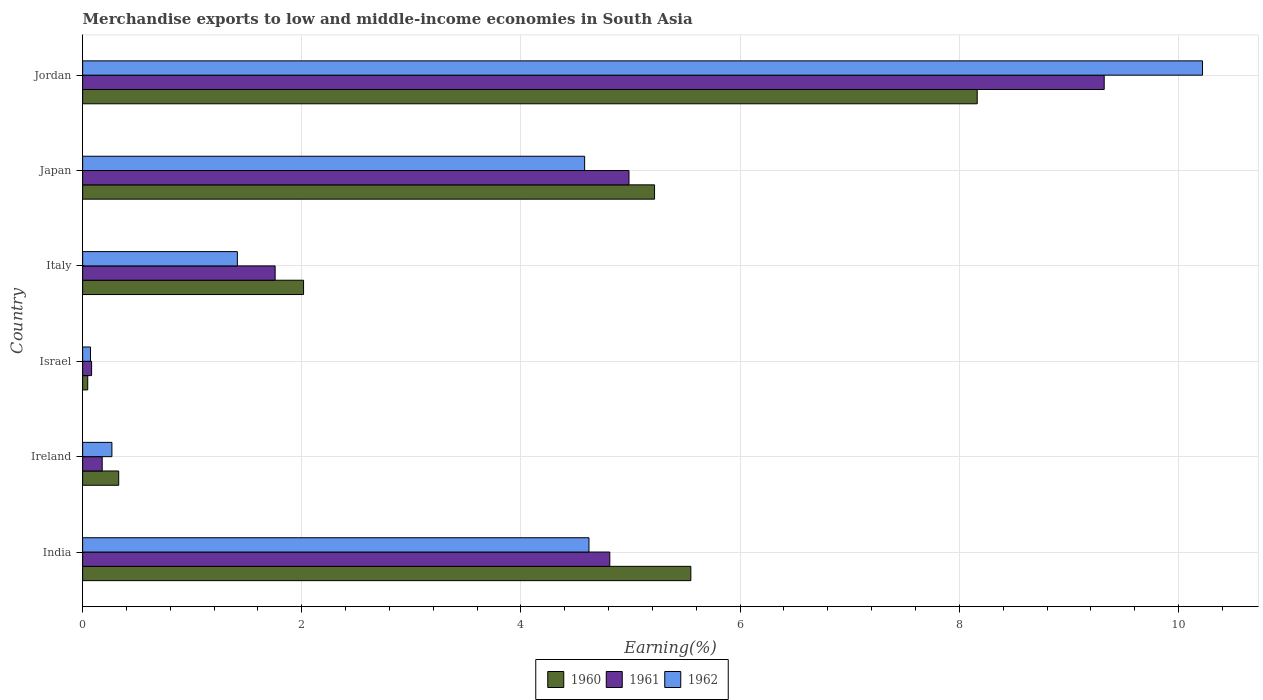How many different coloured bars are there?
Ensure brevity in your answer.  3. Are the number of bars per tick equal to the number of legend labels?
Your answer should be very brief. Yes. Are the number of bars on each tick of the Y-axis equal?
Offer a terse response. Yes. How many bars are there on the 3rd tick from the top?
Your response must be concise. 3. How many bars are there on the 2nd tick from the bottom?
Offer a very short reply. 3. What is the label of the 4th group of bars from the top?
Keep it short and to the point. Israel. In how many cases, is the number of bars for a given country not equal to the number of legend labels?
Offer a very short reply. 0. What is the percentage of amount earned from merchandise exports in 1960 in Jordan?
Your answer should be compact. 8.16. Across all countries, what is the maximum percentage of amount earned from merchandise exports in 1961?
Your answer should be very brief. 9.32. Across all countries, what is the minimum percentage of amount earned from merchandise exports in 1961?
Give a very brief answer. 0.08. In which country was the percentage of amount earned from merchandise exports in 1962 maximum?
Provide a succinct answer. Jordan. What is the total percentage of amount earned from merchandise exports in 1961 in the graph?
Your answer should be very brief. 21.13. What is the difference between the percentage of amount earned from merchandise exports in 1962 in Israel and that in Italy?
Offer a very short reply. -1.34. What is the difference between the percentage of amount earned from merchandise exports in 1960 in India and the percentage of amount earned from merchandise exports in 1961 in Ireland?
Keep it short and to the point. 5.37. What is the average percentage of amount earned from merchandise exports in 1962 per country?
Your response must be concise. 3.53. What is the difference between the percentage of amount earned from merchandise exports in 1961 and percentage of amount earned from merchandise exports in 1962 in Ireland?
Give a very brief answer. -0.09. In how many countries, is the percentage of amount earned from merchandise exports in 1962 greater than 4.4 %?
Ensure brevity in your answer.  3. What is the ratio of the percentage of amount earned from merchandise exports in 1962 in India to that in Ireland?
Provide a short and direct response. 17.29. Is the percentage of amount earned from merchandise exports in 1961 in Israel less than that in Japan?
Provide a succinct answer. Yes. What is the difference between the highest and the second highest percentage of amount earned from merchandise exports in 1960?
Give a very brief answer. 2.61. What is the difference between the highest and the lowest percentage of amount earned from merchandise exports in 1961?
Provide a succinct answer. 9.24. In how many countries, is the percentage of amount earned from merchandise exports in 1960 greater than the average percentage of amount earned from merchandise exports in 1960 taken over all countries?
Your answer should be very brief. 3. Is the sum of the percentage of amount earned from merchandise exports in 1962 in Ireland and Israel greater than the maximum percentage of amount earned from merchandise exports in 1960 across all countries?
Make the answer very short. No. What does the 3rd bar from the bottom in Japan represents?
Offer a very short reply. 1962. Is it the case that in every country, the sum of the percentage of amount earned from merchandise exports in 1962 and percentage of amount earned from merchandise exports in 1961 is greater than the percentage of amount earned from merchandise exports in 1960?
Provide a succinct answer. Yes. Are all the bars in the graph horizontal?
Your response must be concise. Yes. How many countries are there in the graph?
Offer a very short reply. 6. What is the difference between two consecutive major ticks on the X-axis?
Your answer should be compact. 2. Where does the legend appear in the graph?
Offer a terse response. Bottom center. How many legend labels are there?
Offer a terse response. 3. How are the legend labels stacked?
Provide a succinct answer. Horizontal. What is the title of the graph?
Ensure brevity in your answer.  Merchandise exports to low and middle-income economies in South Asia. What is the label or title of the X-axis?
Provide a succinct answer. Earning(%). What is the Earning(%) in 1960 in India?
Give a very brief answer. 5.55. What is the Earning(%) of 1961 in India?
Your answer should be very brief. 4.81. What is the Earning(%) of 1962 in India?
Your answer should be compact. 4.62. What is the Earning(%) in 1960 in Ireland?
Offer a terse response. 0.33. What is the Earning(%) in 1961 in Ireland?
Provide a succinct answer. 0.18. What is the Earning(%) of 1962 in Ireland?
Make the answer very short. 0.27. What is the Earning(%) in 1960 in Israel?
Provide a short and direct response. 0.05. What is the Earning(%) of 1961 in Israel?
Offer a very short reply. 0.08. What is the Earning(%) in 1962 in Israel?
Offer a very short reply. 0.07. What is the Earning(%) of 1960 in Italy?
Your answer should be very brief. 2.02. What is the Earning(%) in 1961 in Italy?
Provide a succinct answer. 1.76. What is the Earning(%) in 1962 in Italy?
Ensure brevity in your answer.  1.41. What is the Earning(%) in 1960 in Japan?
Give a very brief answer. 5.22. What is the Earning(%) in 1961 in Japan?
Offer a very short reply. 4.99. What is the Earning(%) of 1962 in Japan?
Give a very brief answer. 4.58. What is the Earning(%) in 1960 in Jordan?
Provide a succinct answer. 8.16. What is the Earning(%) in 1961 in Jordan?
Give a very brief answer. 9.32. What is the Earning(%) of 1962 in Jordan?
Your answer should be compact. 10.22. Across all countries, what is the maximum Earning(%) in 1960?
Provide a short and direct response. 8.16. Across all countries, what is the maximum Earning(%) in 1961?
Provide a short and direct response. 9.32. Across all countries, what is the maximum Earning(%) of 1962?
Your answer should be compact. 10.22. Across all countries, what is the minimum Earning(%) of 1960?
Give a very brief answer. 0.05. Across all countries, what is the minimum Earning(%) of 1961?
Ensure brevity in your answer.  0.08. Across all countries, what is the minimum Earning(%) in 1962?
Make the answer very short. 0.07. What is the total Earning(%) of 1960 in the graph?
Your answer should be compact. 21.32. What is the total Earning(%) in 1961 in the graph?
Keep it short and to the point. 21.14. What is the total Earning(%) of 1962 in the graph?
Make the answer very short. 21.17. What is the difference between the Earning(%) in 1960 in India and that in Ireland?
Provide a succinct answer. 5.22. What is the difference between the Earning(%) in 1961 in India and that in Ireland?
Your response must be concise. 4.63. What is the difference between the Earning(%) in 1962 in India and that in Ireland?
Make the answer very short. 4.35. What is the difference between the Earning(%) of 1960 in India and that in Israel?
Provide a short and direct response. 5.5. What is the difference between the Earning(%) of 1961 in India and that in Israel?
Keep it short and to the point. 4.73. What is the difference between the Earning(%) of 1962 in India and that in Israel?
Your response must be concise. 4.55. What is the difference between the Earning(%) of 1960 in India and that in Italy?
Offer a very short reply. 3.53. What is the difference between the Earning(%) in 1961 in India and that in Italy?
Provide a short and direct response. 3.05. What is the difference between the Earning(%) in 1962 in India and that in Italy?
Provide a short and direct response. 3.21. What is the difference between the Earning(%) of 1960 in India and that in Japan?
Give a very brief answer. 0.33. What is the difference between the Earning(%) in 1961 in India and that in Japan?
Offer a very short reply. -0.17. What is the difference between the Earning(%) in 1962 in India and that in Japan?
Offer a very short reply. 0.04. What is the difference between the Earning(%) of 1960 in India and that in Jordan?
Keep it short and to the point. -2.61. What is the difference between the Earning(%) in 1961 in India and that in Jordan?
Your response must be concise. -4.51. What is the difference between the Earning(%) in 1962 in India and that in Jordan?
Provide a succinct answer. -5.6. What is the difference between the Earning(%) in 1960 in Ireland and that in Israel?
Offer a very short reply. 0.28. What is the difference between the Earning(%) in 1961 in Ireland and that in Israel?
Offer a terse response. 0.1. What is the difference between the Earning(%) in 1962 in Ireland and that in Israel?
Provide a short and direct response. 0.2. What is the difference between the Earning(%) in 1960 in Ireland and that in Italy?
Give a very brief answer. -1.69. What is the difference between the Earning(%) in 1961 in Ireland and that in Italy?
Offer a very short reply. -1.58. What is the difference between the Earning(%) of 1962 in Ireland and that in Italy?
Ensure brevity in your answer.  -1.14. What is the difference between the Earning(%) of 1960 in Ireland and that in Japan?
Offer a terse response. -4.89. What is the difference between the Earning(%) in 1961 in Ireland and that in Japan?
Keep it short and to the point. -4.81. What is the difference between the Earning(%) of 1962 in Ireland and that in Japan?
Make the answer very short. -4.31. What is the difference between the Earning(%) in 1960 in Ireland and that in Jordan?
Ensure brevity in your answer.  -7.83. What is the difference between the Earning(%) of 1961 in Ireland and that in Jordan?
Make the answer very short. -9.14. What is the difference between the Earning(%) in 1962 in Ireland and that in Jordan?
Provide a short and direct response. -9.95. What is the difference between the Earning(%) in 1960 in Israel and that in Italy?
Your answer should be compact. -1.97. What is the difference between the Earning(%) in 1961 in Israel and that in Italy?
Provide a succinct answer. -1.68. What is the difference between the Earning(%) in 1962 in Israel and that in Italy?
Give a very brief answer. -1.34. What is the difference between the Earning(%) of 1960 in Israel and that in Japan?
Provide a short and direct response. -5.17. What is the difference between the Earning(%) of 1961 in Israel and that in Japan?
Offer a terse response. -4.9. What is the difference between the Earning(%) in 1962 in Israel and that in Japan?
Ensure brevity in your answer.  -4.51. What is the difference between the Earning(%) in 1960 in Israel and that in Jordan?
Offer a terse response. -8.12. What is the difference between the Earning(%) in 1961 in Israel and that in Jordan?
Ensure brevity in your answer.  -9.24. What is the difference between the Earning(%) of 1962 in Israel and that in Jordan?
Offer a very short reply. -10.15. What is the difference between the Earning(%) of 1960 in Italy and that in Japan?
Give a very brief answer. -3.2. What is the difference between the Earning(%) in 1961 in Italy and that in Japan?
Your answer should be very brief. -3.23. What is the difference between the Earning(%) in 1962 in Italy and that in Japan?
Your response must be concise. -3.17. What is the difference between the Earning(%) in 1960 in Italy and that in Jordan?
Give a very brief answer. -6.15. What is the difference between the Earning(%) of 1961 in Italy and that in Jordan?
Make the answer very short. -7.57. What is the difference between the Earning(%) in 1962 in Italy and that in Jordan?
Ensure brevity in your answer.  -8.81. What is the difference between the Earning(%) in 1960 in Japan and that in Jordan?
Provide a short and direct response. -2.94. What is the difference between the Earning(%) in 1961 in Japan and that in Jordan?
Ensure brevity in your answer.  -4.34. What is the difference between the Earning(%) of 1962 in Japan and that in Jordan?
Offer a very short reply. -5.64. What is the difference between the Earning(%) in 1960 in India and the Earning(%) in 1961 in Ireland?
Provide a short and direct response. 5.37. What is the difference between the Earning(%) in 1960 in India and the Earning(%) in 1962 in Ireland?
Give a very brief answer. 5.28. What is the difference between the Earning(%) in 1961 in India and the Earning(%) in 1962 in Ireland?
Provide a short and direct response. 4.54. What is the difference between the Earning(%) in 1960 in India and the Earning(%) in 1961 in Israel?
Offer a terse response. 5.47. What is the difference between the Earning(%) of 1960 in India and the Earning(%) of 1962 in Israel?
Your answer should be compact. 5.48. What is the difference between the Earning(%) of 1961 in India and the Earning(%) of 1962 in Israel?
Provide a short and direct response. 4.74. What is the difference between the Earning(%) in 1960 in India and the Earning(%) in 1961 in Italy?
Give a very brief answer. 3.79. What is the difference between the Earning(%) of 1960 in India and the Earning(%) of 1962 in Italy?
Offer a very short reply. 4.14. What is the difference between the Earning(%) of 1961 in India and the Earning(%) of 1962 in Italy?
Offer a terse response. 3.4. What is the difference between the Earning(%) of 1960 in India and the Earning(%) of 1961 in Japan?
Offer a very short reply. 0.56. What is the difference between the Earning(%) of 1960 in India and the Earning(%) of 1962 in Japan?
Keep it short and to the point. 0.97. What is the difference between the Earning(%) in 1961 in India and the Earning(%) in 1962 in Japan?
Make the answer very short. 0.23. What is the difference between the Earning(%) in 1960 in India and the Earning(%) in 1961 in Jordan?
Your response must be concise. -3.77. What is the difference between the Earning(%) of 1960 in India and the Earning(%) of 1962 in Jordan?
Your answer should be very brief. -4.67. What is the difference between the Earning(%) of 1961 in India and the Earning(%) of 1962 in Jordan?
Your answer should be very brief. -5.41. What is the difference between the Earning(%) in 1960 in Ireland and the Earning(%) in 1961 in Israel?
Make the answer very short. 0.25. What is the difference between the Earning(%) in 1960 in Ireland and the Earning(%) in 1962 in Israel?
Make the answer very short. 0.26. What is the difference between the Earning(%) in 1961 in Ireland and the Earning(%) in 1962 in Israel?
Your answer should be very brief. 0.11. What is the difference between the Earning(%) of 1960 in Ireland and the Earning(%) of 1961 in Italy?
Keep it short and to the point. -1.43. What is the difference between the Earning(%) of 1960 in Ireland and the Earning(%) of 1962 in Italy?
Your answer should be compact. -1.08. What is the difference between the Earning(%) in 1961 in Ireland and the Earning(%) in 1962 in Italy?
Provide a short and direct response. -1.23. What is the difference between the Earning(%) of 1960 in Ireland and the Earning(%) of 1961 in Japan?
Keep it short and to the point. -4.66. What is the difference between the Earning(%) of 1960 in Ireland and the Earning(%) of 1962 in Japan?
Provide a succinct answer. -4.25. What is the difference between the Earning(%) in 1961 in Ireland and the Earning(%) in 1962 in Japan?
Provide a short and direct response. -4.4. What is the difference between the Earning(%) in 1960 in Ireland and the Earning(%) in 1961 in Jordan?
Ensure brevity in your answer.  -8.99. What is the difference between the Earning(%) of 1960 in Ireland and the Earning(%) of 1962 in Jordan?
Ensure brevity in your answer.  -9.89. What is the difference between the Earning(%) of 1961 in Ireland and the Earning(%) of 1962 in Jordan?
Make the answer very short. -10.04. What is the difference between the Earning(%) in 1960 in Israel and the Earning(%) in 1961 in Italy?
Offer a very short reply. -1.71. What is the difference between the Earning(%) of 1960 in Israel and the Earning(%) of 1962 in Italy?
Offer a terse response. -1.37. What is the difference between the Earning(%) of 1961 in Israel and the Earning(%) of 1962 in Italy?
Your answer should be compact. -1.33. What is the difference between the Earning(%) of 1960 in Israel and the Earning(%) of 1961 in Japan?
Ensure brevity in your answer.  -4.94. What is the difference between the Earning(%) in 1960 in Israel and the Earning(%) in 1962 in Japan?
Provide a succinct answer. -4.53. What is the difference between the Earning(%) in 1961 in Israel and the Earning(%) in 1962 in Japan?
Give a very brief answer. -4.5. What is the difference between the Earning(%) in 1960 in Israel and the Earning(%) in 1961 in Jordan?
Ensure brevity in your answer.  -9.28. What is the difference between the Earning(%) of 1960 in Israel and the Earning(%) of 1962 in Jordan?
Provide a succinct answer. -10.17. What is the difference between the Earning(%) of 1961 in Israel and the Earning(%) of 1962 in Jordan?
Make the answer very short. -10.14. What is the difference between the Earning(%) of 1960 in Italy and the Earning(%) of 1961 in Japan?
Give a very brief answer. -2.97. What is the difference between the Earning(%) in 1960 in Italy and the Earning(%) in 1962 in Japan?
Keep it short and to the point. -2.56. What is the difference between the Earning(%) of 1961 in Italy and the Earning(%) of 1962 in Japan?
Your answer should be very brief. -2.82. What is the difference between the Earning(%) in 1960 in Italy and the Earning(%) in 1961 in Jordan?
Keep it short and to the point. -7.31. What is the difference between the Earning(%) of 1960 in Italy and the Earning(%) of 1962 in Jordan?
Offer a terse response. -8.2. What is the difference between the Earning(%) in 1961 in Italy and the Earning(%) in 1962 in Jordan?
Your answer should be compact. -8.46. What is the difference between the Earning(%) of 1960 in Japan and the Earning(%) of 1961 in Jordan?
Make the answer very short. -4.1. What is the difference between the Earning(%) in 1960 in Japan and the Earning(%) in 1962 in Jordan?
Offer a very short reply. -5. What is the difference between the Earning(%) of 1961 in Japan and the Earning(%) of 1962 in Jordan?
Offer a very short reply. -5.23. What is the average Earning(%) in 1960 per country?
Keep it short and to the point. 3.55. What is the average Earning(%) of 1961 per country?
Your response must be concise. 3.52. What is the average Earning(%) in 1962 per country?
Your answer should be very brief. 3.53. What is the difference between the Earning(%) of 1960 and Earning(%) of 1961 in India?
Ensure brevity in your answer.  0.74. What is the difference between the Earning(%) of 1960 and Earning(%) of 1962 in India?
Offer a very short reply. 0.93. What is the difference between the Earning(%) in 1961 and Earning(%) in 1962 in India?
Give a very brief answer. 0.19. What is the difference between the Earning(%) in 1960 and Earning(%) in 1961 in Ireland?
Your answer should be very brief. 0.15. What is the difference between the Earning(%) of 1960 and Earning(%) of 1962 in Ireland?
Provide a short and direct response. 0.06. What is the difference between the Earning(%) of 1961 and Earning(%) of 1962 in Ireland?
Offer a terse response. -0.09. What is the difference between the Earning(%) in 1960 and Earning(%) in 1961 in Israel?
Provide a succinct answer. -0.04. What is the difference between the Earning(%) in 1960 and Earning(%) in 1962 in Israel?
Keep it short and to the point. -0.03. What is the difference between the Earning(%) in 1961 and Earning(%) in 1962 in Israel?
Make the answer very short. 0.01. What is the difference between the Earning(%) of 1960 and Earning(%) of 1961 in Italy?
Offer a terse response. 0.26. What is the difference between the Earning(%) in 1960 and Earning(%) in 1962 in Italy?
Make the answer very short. 0.6. What is the difference between the Earning(%) in 1961 and Earning(%) in 1962 in Italy?
Provide a short and direct response. 0.34. What is the difference between the Earning(%) in 1960 and Earning(%) in 1961 in Japan?
Your answer should be compact. 0.23. What is the difference between the Earning(%) in 1960 and Earning(%) in 1962 in Japan?
Offer a terse response. 0.64. What is the difference between the Earning(%) in 1961 and Earning(%) in 1962 in Japan?
Ensure brevity in your answer.  0.4. What is the difference between the Earning(%) of 1960 and Earning(%) of 1961 in Jordan?
Make the answer very short. -1.16. What is the difference between the Earning(%) in 1960 and Earning(%) in 1962 in Jordan?
Give a very brief answer. -2.06. What is the difference between the Earning(%) in 1961 and Earning(%) in 1962 in Jordan?
Your answer should be compact. -0.9. What is the ratio of the Earning(%) of 1960 in India to that in Ireland?
Keep it short and to the point. 16.86. What is the ratio of the Earning(%) of 1961 in India to that in Ireland?
Your answer should be very brief. 26.95. What is the ratio of the Earning(%) in 1962 in India to that in Ireland?
Your answer should be very brief. 17.29. What is the ratio of the Earning(%) in 1960 in India to that in Israel?
Give a very brief answer. 119.1. What is the ratio of the Earning(%) of 1961 in India to that in Israel?
Make the answer very short. 58.86. What is the ratio of the Earning(%) in 1962 in India to that in Israel?
Give a very brief answer. 64.18. What is the ratio of the Earning(%) in 1960 in India to that in Italy?
Ensure brevity in your answer.  2.75. What is the ratio of the Earning(%) of 1961 in India to that in Italy?
Make the answer very short. 2.74. What is the ratio of the Earning(%) in 1962 in India to that in Italy?
Keep it short and to the point. 3.27. What is the ratio of the Earning(%) of 1960 in India to that in Japan?
Offer a very short reply. 1.06. What is the ratio of the Earning(%) of 1961 in India to that in Japan?
Your answer should be very brief. 0.96. What is the ratio of the Earning(%) of 1962 in India to that in Japan?
Offer a terse response. 1.01. What is the ratio of the Earning(%) of 1960 in India to that in Jordan?
Your answer should be very brief. 0.68. What is the ratio of the Earning(%) of 1961 in India to that in Jordan?
Your response must be concise. 0.52. What is the ratio of the Earning(%) in 1962 in India to that in Jordan?
Your answer should be compact. 0.45. What is the ratio of the Earning(%) in 1960 in Ireland to that in Israel?
Give a very brief answer. 7.06. What is the ratio of the Earning(%) of 1961 in Ireland to that in Israel?
Give a very brief answer. 2.18. What is the ratio of the Earning(%) in 1962 in Ireland to that in Israel?
Ensure brevity in your answer.  3.71. What is the ratio of the Earning(%) of 1960 in Ireland to that in Italy?
Ensure brevity in your answer.  0.16. What is the ratio of the Earning(%) in 1961 in Ireland to that in Italy?
Your answer should be very brief. 0.1. What is the ratio of the Earning(%) of 1962 in Ireland to that in Italy?
Your answer should be very brief. 0.19. What is the ratio of the Earning(%) in 1960 in Ireland to that in Japan?
Your response must be concise. 0.06. What is the ratio of the Earning(%) in 1961 in Ireland to that in Japan?
Make the answer very short. 0.04. What is the ratio of the Earning(%) of 1962 in Ireland to that in Japan?
Ensure brevity in your answer.  0.06. What is the ratio of the Earning(%) in 1960 in Ireland to that in Jordan?
Provide a succinct answer. 0.04. What is the ratio of the Earning(%) in 1961 in Ireland to that in Jordan?
Provide a short and direct response. 0.02. What is the ratio of the Earning(%) in 1962 in Ireland to that in Jordan?
Your answer should be very brief. 0.03. What is the ratio of the Earning(%) in 1960 in Israel to that in Italy?
Ensure brevity in your answer.  0.02. What is the ratio of the Earning(%) in 1961 in Israel to that in Italy?
Your response must be concise. 0.05. What is the ratio of the Earning(%) in 1962 in Israel to that in Italy?
Offer a very short reply. 0.05. What is the ratio of the Earning(%) of 1960 in Israel to that in Japan?
Your answer should be very brief. 0.01. What is the ratio of the Earning(%) in 1961 in Israel to that in Japan?
Provide a succinct answer. 0.02. What is the ratio of the Earning(%) of 1962 in Israel to that in Japan?
Provide a succinct answer. 0.02. What is the ratio of the Earning(%) of 1960 in Israel to that in Jordan?
Your answer should be compact. 0.01. What is the ratio of the Earning(%) of 1961 in Israel to that in Jordan?
Your answer should be compact. 0.01. What is the ratio of the Earning(%) of 1962 in Israel to that in Jordan?
Make the answer very short. 0.01. What is the ratio of the Earning(%) of 1960 in Italy to that in Japan?
Provide a short and direct response. 0.39. What is the ratio of the Earning(%) in 1961 in Italy to that in Japan?
Provide a short and direct response. 0.35. What is the ratio of the Earning(%) in 1962 in Italy to that in Japan?
Your answer should be very brief. 0.31. What is the ratio of the Earning(%) of 1960 in Italy to that in Jordan?
Offer a very short reply. 0.25. What is the ratio of the Earning(%) in 1961 in Italy to that in Jordan?
Provide a succinct answer. 0.19. What is the ratio of the Earning(%) of 1962 in Italy to that in Jordan?
Your answer should be compact. 0.14. What is the ratio of the Earning(%) of 1960 in Japan to that in Jordan?
Keep it short and to the point. 0.64. What is the ratio of the Earning(%) in 1961 in Japan to that in Jordan?
Make the answer very short. 0.53. What is the ratio of the Earning(%) of 1962 in Japan to that in Jordan?
Make the answer very short. 0.45. What is the difference between the highest and the second highest Earning(%) of 1960?
Your answer should be compact. 2.61. What is the difference between the highest and the second highest Earning(%) of 1961?
Offer a terse response. 4.34. What is the difference between the highest and the second highest Earning(%) of 1962?
Ensure brevity in your answer.  5.6. What is the difference between the highest and the lowest Earning(%) of 1960?
Ensure brevity in your answer.  8.12. What is the difference between the highest and the lowest Earning(%) in 1961?
Keep it short and to the point. 9.24. What is the difference between the highest and the lowest Earning(%) of 1962?
Provide a succinct answer. 10.15. 